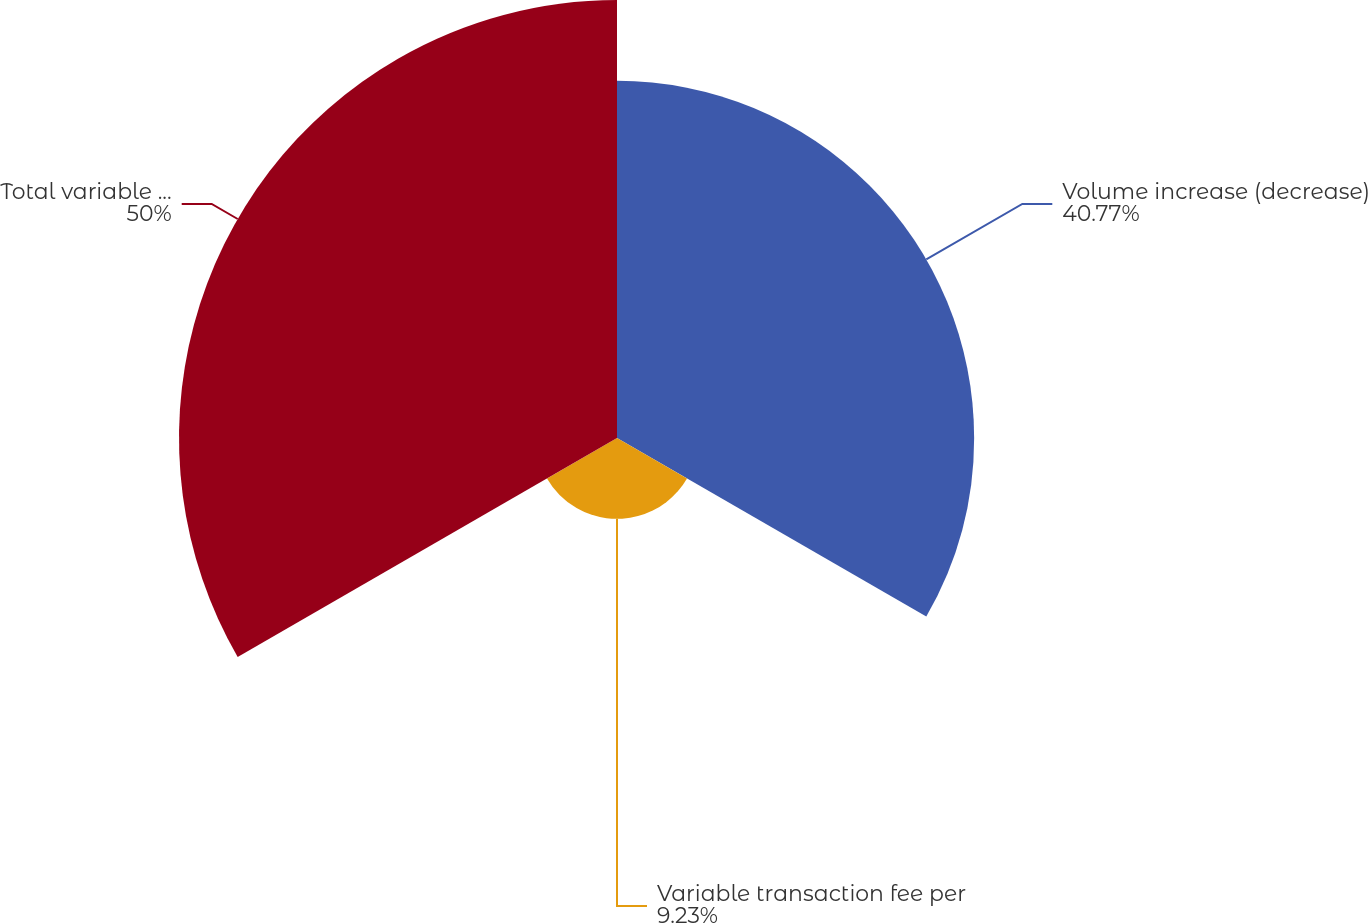Convert chart. <chart><loc_0><loc_0><loc_500><loc_500><pie_chart><fcel>Volume increase (decrease)<fcel>Variable transaction fee per<fcel>Total variable commissions<nl><fcel>40.77%<fcel>9.23%<fcel>50.0%<nl></chart> 